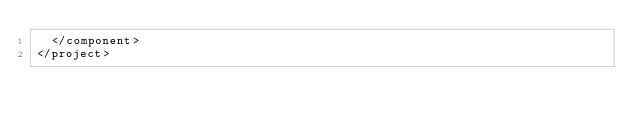<code> <loc_0><loc_0><loc_500><loc_500><_XML_>  </component>
</project></code> 